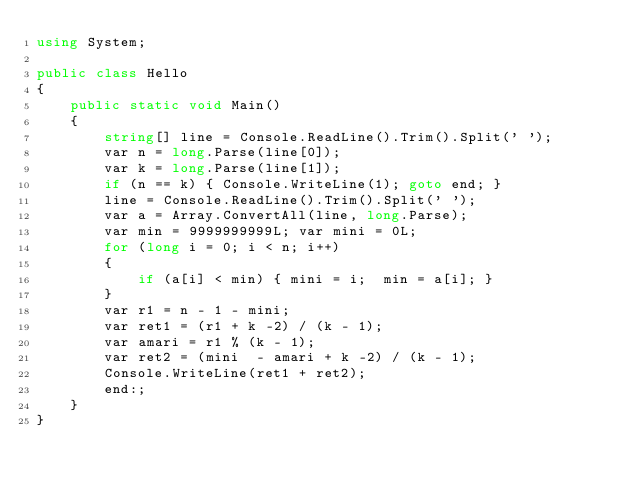Convert code to text. <code><loc_0><loc_0><loc_500><loc_500><_C#_>using System;

public class Hello
{
    public static void Main()
    {
        string[] line = Console.ReadLine().Trim().Split(' ');
        var n = long.Parse(line[0]);
        var k = long.Parse(line[1]);
        if (n == k) { Console.WriteLine(1); goto end; }
        line = Console.ReadLine().Trim().Split(' ');
        var a = Array.ConvertAll(line, long.Parse);
        var min = 9999999999L; var mini = 0L;
        for (long i = 0; i < n; i++)
        {
            if (a[i] < min) { mini = i;  min = a[i]; }
        }
        var r1 = n - 1 - mini;
        var ret1 = (r1 + k -2) / (k - 1);
        var amari = r1 % (k - 1);
        var ret2 = (mini  - amari + k -2) / (k - 1);
        Console.WriteLine(ret1 + ret2);
        end:;
    }
}</code> 